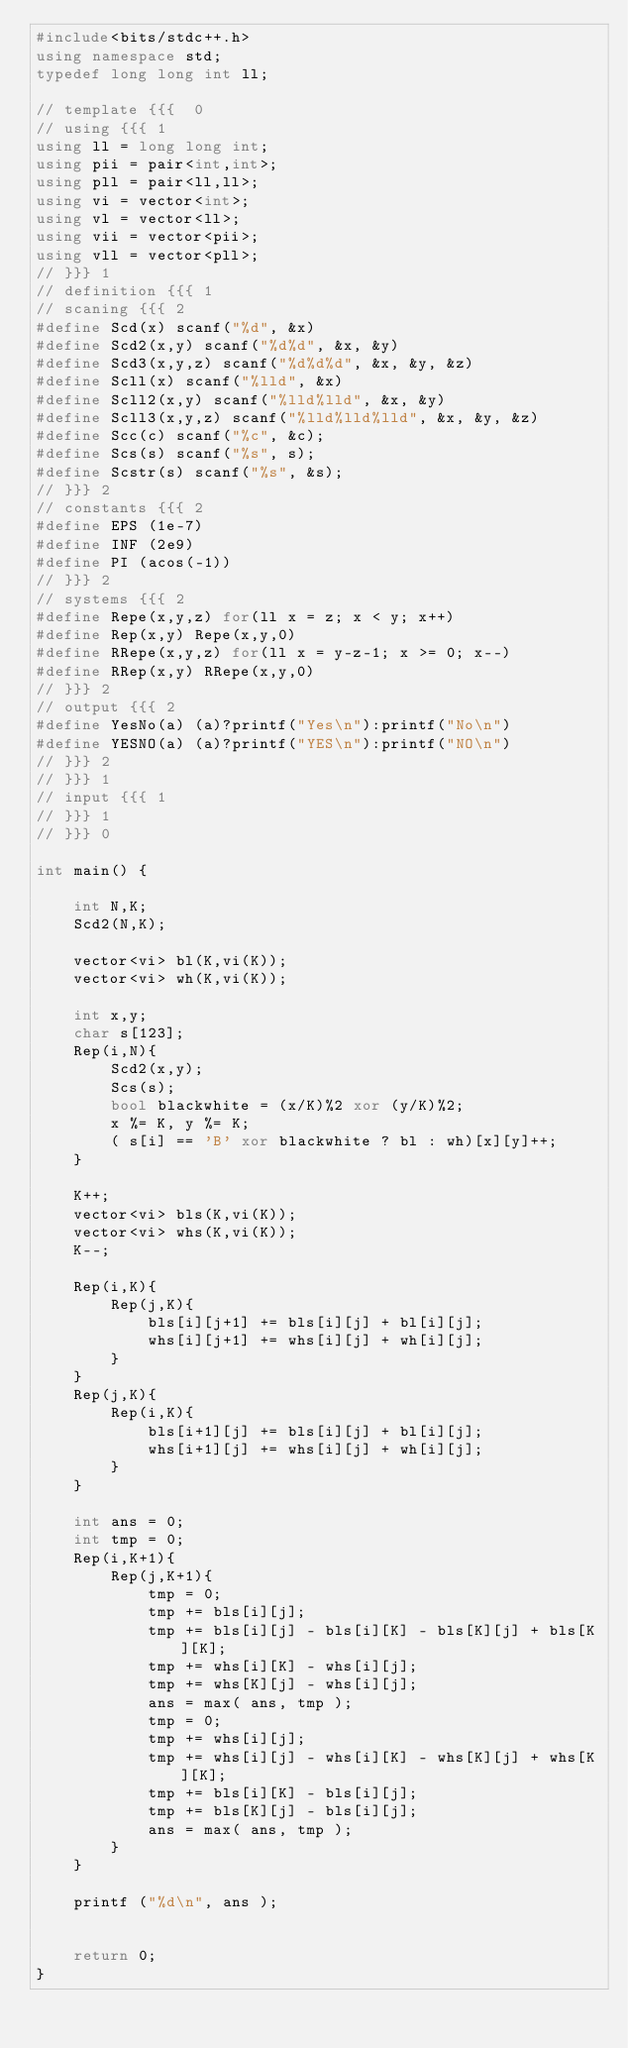Convert code to text. <code><loc_0><loc_0><loc_500><loc_500><_C++_>#include<bits/stdc++.h>
using namespace std;
typedef long long int ll;

// template {{{  0 
// using {{{ 1
using ll = long long int;
using pii = pair<int,int>;
using pll = pair<ll,ll>;
using vi = vector<int>;
using vl = vector<ll>;
using vii = vector<pii>;
using vll = vector<pll>;
// }}} 1
// definition {{{ 1
// scaning {{{ 2
#define Scd(x) scanf("%d", &x)
#define Scd2(x,y) scanf("%d%d", &x, &y)
#define Scd3(x,y,z) scanf("%d%d%d", &x, &y, &z)
#define Scll(x) scanf("%lld", &x)
#define Scll2(x,y) scanf("%lld%lld", &x, &y)
#define Scll3(x,y,z) scanf("%lld%lld%lld", &x, &y, &z)
#define Scc(c) scanf("%c", &c);
#define Scs(s) scanf("%s", s);
#define Scstr(s) scanf("%s", &s);
// }}} 2
// constants {{{ 2
#define EPS (1e-7)
#define INF (2e9)
#define PI (acos(-1))
// }}} 2
// systems {{{ 2
#define Repe(x,y,z) for(ll x = z; x < y; x++)
#define Rep(x,y) Repe(x,y,0)
#define RRepe(x,y,z) for(ll x = y-z-1; x >= 0; x--)
#define RRep(x,y) RRepe(x,y,0)
// }}} 2
// output {{{ 2
#define YesNo(a) (a)?printf("Yes\n"):printf("No\n")
#define YESNO(a) (a)?printf("YES\n"):printf("NO\n")
// }}} 2
// }}} 1
// input {{{ 1
// }}} 1
// }}} 0

int main() {

    int N,K;
    Scd2(N,K);

    vector<vi> bl(K,vi(K));
    vector<vi> wh(K,vi(K));

    int x,y;
    char s[123];
    Rep(i,N){
        Scd2(x,y);
        Scs(s);
        bool blackwhite = (x/K)%2 xor (y/K)%2;
        x %= K, y %= K;
        ( s[i] == 'B' xor blackwhite ? bl : wh)[x][y]++;
    }

    K++;
    vector<vi> bls(K,vi(K));
    vector<vi> whs(K,vi(K));
    K--;

    Rep(i,K){
        Rep(j,K){
            bls[i][j+1] += bls[i][j] + bl[i][j];
            whs[i][j+1] += whs[i][j] + wh[i][j];
        }
    }
    Rep(j,K){
        Rep(i,K){
            bls[i+1][j] += bls[i][j] + bl[i][j];
            whs[i+1][j] += whs[i][j] + wh[i][j];
        }
    }

    int ans = 0;
    int tmp = 0;
    Rep(i,K+1){
        Rep(j,K+1){
            tmp = 0;
            tmp += bls[i][j];
            tmp += bls[i][j] - bls[i][K] - bls[K][j] + bls[K][K];
            tmp += whs[i][K] - whs[i][j];
            tmp += whs[K][j] - whs[i][j];
            ans = max( ans, tmp );
            tmp = 0;
            tmp += whs[i][j];
            tmp += whs[i][j] - whs[i][K] - whs[K][j] + whs[K][K];
            tmp += bls[i][K] - bls[i][j];
            tmp += bls[K][j] - bls[i][j];
            ans = max( ans, tmp );
        }
    }

    printf ("%d\n", ans );


    return 0;
}



</code> 